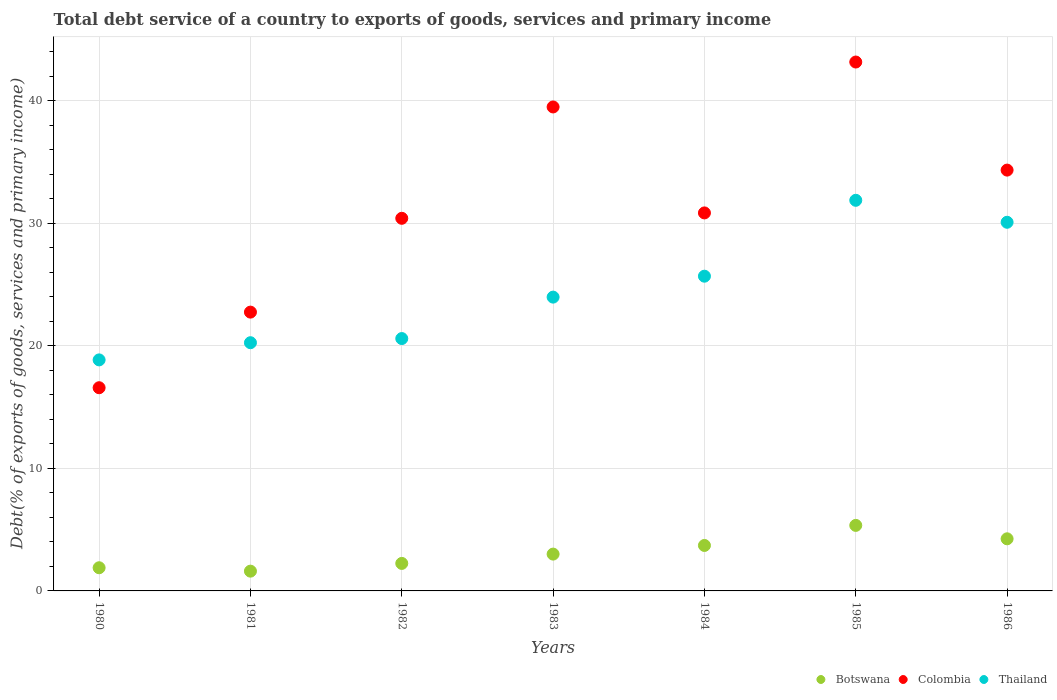How many different coloured dotlines are there?
Ensure brevity in your answer.  3. Is the number of dotlines equal to the number of legend labels?
Make the answer very short. Yes. What is the total debt service in Colombia in 1985?
Offer a very short reply. 43.18. Across all years, what is the maximum total debt service in Colombia?
Make the answer very short. 43.18. Across all years, what is the minimum total debt service in Colombia?
Give a very brief answer. 16.59. In which year was the total debt service in Colombia maximum?
Offer a very short reply. 1985. What is the total total debt service in Botswana in the graph?
Keep it short and to the point. 22.07. What is the difference between the total debt service in Colombia in 1981 and that in 1983?
Offer a very short reply. -16.75. What is the difference between the total debt service in Thailand in 1984 and the total debt service in Botswana in 1986?
Your response must be concise. 21.44. What is the average total debt service in Botswana per year?
Make the answer very short. 3.15. In the year 1985, what is the difference between the total debt service in Colombia and total debt service in Thailand?
Offer a very short reply. 11.29. In how many years, is the total debt service in Colombia greater than 8 %?
Provide a succinct answer. 7. What is the ratio of the total debt service in Botswana in 1983 to that in 1985?
Give a very brief answer. 0.56. Is the total debt service in Colombia in 1981 less than that in 1982?
Your response must be concise. Yes. Is the difference between the total debt service in Colombia in 1984 and 1986 greater than the difference between the total debt service in Thailand in 1984 and 1986?
Offer a very short reply. Yes. What is the difference between the highest and the second highest total debt service in Botswana?
Make the answer very short. 1.1. What is the difference between the highest and the lowest total debt service in Thailand?
Keep it short and to the point. 13.03. Is the sum of the total debt service in Botswana in 1981 and 1982 greater than the maximum total debt service in Colombia across all years?
Your answer should be compact. No. Is it the case that in every year, the sum of the total debt service in Colombia and total debt service in Botswana  is greater than the total debt service in Thailand?
Provide a succinct answer. No. Is the total debt service in Colombia strictly less than the total debt service in Botswana over the years?
Offer a terse response. No. How many years are there in the graph?
Keep it short and to the point. 7. Does the graph contain any zero values?
Your answer should be very brief. No. Does the graph contain grids?
Provide a short and direct response. Yes. How many legend labels are there?
Offer a very short reply. 3. How are the legend labels stacked?
Keep it short and to the point. Horizontal. What is the title of the graph?
Provide a short and direct response. Total debt service of a country to exports of goods, services and primary income. What is the label or title of the Y-axis?
Provide a short and direct response. Debt(% of exports of goods, services and primary income). What is the Debt(% of exports of goods, services and primary income) in Botswana in 1980?
Offer a very short reply. 1.89. What is the Debt(% of exports of goods, services and primary income) of Colombia in 1980?
Ensure brevity in your answer.  16.59. What is the Debt(% of exports of goods, services and primary income) of Thailand in 1980?
Your response must be concise. 18.86. What is the Debt(% of exports of goods, services and primary income) of Botswana in 1981?
Your answer should be very brief. 1.61. What is the Debt(% of exports of goods, services and primary income) of Colombia in 1981?
Keep it short and to the point. 22.76. What is the Debt(% of exports of goods, services and primary income) in Thailand in 1981?
Give a very brief answer. 20.26. What is the Debt(% of exports of goods, services and primary income) in Botswana in 1982?
Your response must be concise. 2.25. What is the Debt(% of exports of goods, services and primary income) of Colombia in 1982?
Offer a very short reply. 30.42. What is the Debt(% of exports of goods, services and primary income) in Thailand in 1982?
Give a very brief answer. 20.6. What is the Debt(% of exports of goods, services and primary income) of Botswana in 1983?
Your response must be concise. 3.01. What is the Debt(% of exports of goods, services and primary income) in Colombia in 1983?
Provide a short and direct response. 39.51. What is the Debt(% of exports of goods, services and primary income) of Thailand in 1983?
Your answer should be very brief. 23.99. What is the Debt(% of exports of goods, services and primary income) of Botswana in 1984?
Give a very brief answer. 3.71. What is the Debt(% of exports of goods, services and primary income) of Colombia in 1984?
Offer a very short reply. 30.86. What is the Debt(% of exports of goods, services and primary income) in Thailand in 1984?
Provide a short and direct response. 25.7. What is the Debt(% of exports of goods, services and primary income) in Botswana in 1985?
Give a very brief answer. 5.35. What is the Debt(% of exports of goods, services and primary income) in Colombia in 1985?
Make the answer very short. 43.18. What is the Debt(% of exports of goods, services and primary income) in Thailand in 1985?
Your answer should be compact. 31.89. What is the Debt(% of exports of goods, services and primary income) in Botswana in 1986?
Keep it short and to the point. 4.25. What is the Debt(% of exports of goods, services and primary income) in Colombia in 1986?
Your answer should be very brief. 34.36. What is the Debt(% of exports of goods, services and primary income) in Thailand in 1986?
Your answer should be compact. 30.1. Across all years, what is the maximum Debt(% of exports of goods, services and primary income) of Botswana?
Your answer should be very brief. 5.35. Across all years, what is the maximum Debt(% of exports of goods, services and primary income) of Colombia?
Give a very brief answer. 43.18. Across all years, what is the maximum Debt(% of exports of goods, services and primary income) in Thailand?
Provide a short and direct response. 31.89. Across all years, what is the minimum Debt(% of exports of goods, services and primary income) in Botswana?
Your response must be concise. 1.61. Across all years, what is the minimum Debt(% of exports of goods, services and primary income) in Colombia?
Offer a terse response. 16.59. Across all years, what is the minimum Debt(% of exports of goods, services and primary income) of Thailand?
Ensure brevity in your answer.  18.86. What is the total Debt(% of exports of goods, services and primary income) of Botswana in the graph?
Keep it short and to the point. 22.07. What is the total Debt(% of exports of goods, services and primary income) in Colombia in the graph?
Give a very brief answer. 217.69. What is the total Debt(% of exports of goods, services and primary income) of Thailand in the graph?
Your answer should be compact. 171.4. What is the difference between the Debt(% of exports of goods, services and primary income) of Botswana in 1980 and that in 1981?
Give a very brief answer. 0.28. What is the difference between the Debt(% of exports of goods, services and primary income) in Colombia in 1980 and that in 1981?
Your answer should be compact. -6.17. What is the difference between the Debt(% of exports of goods, services and primary income) of Thailand in 1980 and that in 1981?
Provide a succinct answer. -1.4. What is the difference between the Debt(% of exports of goods, services and primary income) of Botswana in 1980 and that in 1982?
Offer a very short reply. -0.35. What is the difference between the Debt(% of exports of goods, services and primary income) of Colombia in 1980 and that in 1982?
Your answer should be very brief. -13.83. What is the difference between the Debt(% of exports of goods, services and primary income) of Thailand in 1980 and that in 1982?
Offer a terse response. -1.74. What is the difference between the Debt(% of exports of goods, services and primary income) in Botswana in 1980 and that in 1983?
Offer a very short reply. -1.11. What is the difference between the Debt(% of exports of goods, services and primary income) of Colombia in 1980 and that in 1983?
Make the answer very short. -22.92. What is the difference between the Debt(% of exports of goods, services and primary income) in Thailand in 1980 and that in 1983?
Your answer should be very brief. -5.12. What is the difference between the Debt(% of exports of goods, services and primary income) in Botswana in 1980 and that in 1984?
Your answer should be compact. -1.82. What is the difference between the Debt(% of exports of goods, services and primary income) of Colombia in 1980 and that in 1984?
Keep it short and to the point. -14.27. What is the difference between the Debt(% of exports of goods, services and primary income) of Thailand in 1980 and that in 1984?
Offer a terse response. -6.83. What is the difference between the Debt(% of exports of goods, services and primary income) in Botswana in 1980 and that in 1985?
Offer a very short reply. -3.46. What is the difference between the Debt(% of exports of goods, services and primary income) of Colombia in 1980 and that in 1985?
Give a very brief answer. -26.59. What is the difference between the Debt(% of exports of goods, services and primary income) of Thailand in 1980 and that in 1985?
Make the answer very short. -13.03. What is the difference between the Debt(% of exports of goods, services and primary income) in Botswana in 1980 and that in 1986?
Ensure brevity in your answer.  -2.36. What is the difference between the Debt(% of exports of goods, services and primary income) of Colombia in 1980 and that in 1986?
Offer a very short reply. -17.77. What is the difference between the Debt(% of exports of goods, services and primary income) of Thailand in 1980 and that in 1986?
Your response must be concise. -11.24. What is the difference between the Debt(% of exports of goods, services and primary income) of Botswana in 1981 and that in 1982?
Make the answer very short. -0.63. What is the difference between the Debt(% of exports of goods, services and primary income) in Colombia in 1981 and that in 1982?
Your response must be concise. -7.66. What is the difference between the Debt(% of exports of goods, services and primary income) in Thailand in 1981 and that in 1982?
Keep it short and to the point. -0.34. What is the difference between the Debt(% of exports of goods, services and primary income) of Botswana in 1981 and that in 1983?
Provide a succinct answer. -1.39. What is the difference between the Debt(% of exports of goods, services and primary income) in Colombia in 1981 and that in 1983?
Keep it short and to the point. -16.75. What is the difference between the Debt(% of exports of goods, services and primary income) in Thailand in 1981 and that in 1983?
Offer a terse response. -3.72. What is the difference between the Debt(% of exports of goods, services and primary income) of Botswana in 1981 and that in 1984?
Keep it short and to the point. -2.1. What is the difference between the Debt(% of exports of goods, services and primary income) in Colombia in 1981 and that in 1984?
Offer a terse response. -8.1. What is the difference between the Debt(% of exports of goods, services and primary income) of Thailand in 1981 and that in 1984?
Make the answer very short. -5.43. What is the difference between the Debt(% of exports of goods, services and primary income) of Botswana in 1981 and that in 1985?
Give a very brief answer. -3.74. What is the difference between the Debt(% of exports of goods, services and primary income) of Colombia in 1981 and that in 1985?
Make the answer very short. -20.42. What is the difference between the Debt(% of exports of goods, services and primary income) in Thailand in 1981 and that in 1985?
Offer a very short reply. -11.63. What is the difference between the Debt(% of exports of goods, services and primary income) in Botswana in 1981 and that in 1986?
Your response must be concise. -2.64. What is the difference between the Debt(% of exports of goods, services and primary income) in Colombia in 1981 and that in 1986?
Give a very brief answer. -11.6. What is the difference between the Debt(% of exports of goods, services and primary income) of Thailand in 1981 and that in 1986?
Your answer should be very brief. -9.83. What is the difference between the Debt(% of exports of goods, services and primary income) of Botswana in 1982 and that in 1983?
Provide a short and direct response. -0.76. What is the difference between the Debt(% of exports of goods, services and primary income) of Colombia in 1982 and that in 1983?
Offer a very short reply. -9.09. What is the difference between the Debt(% of exports of goods, services and primary income) of Thailand in 1982 and that in 1983?
Keep it short and to the point. -3.38. What is the difference between the Debt(% of exports of goods, services and primary income) of Botswana in 1982 and that in 1984?
Offer a very short reply. -1.47. What is the difference between the Debt(% of exports of goods, services and primary income) in Colombia in 1982 and that in 1984?
Provide a succinct answer. -0.44. What is the difference between the Debt(% of exports of goods, services and primary income) in Thailand in 1982 and that in 1984?
Your response must be concise. -5.09. What is the difference between the Debt(% of exports of goods, services and primary income) of Botswana in 1982 and that in 1985?
Ensure brevity in your answer.  -3.1. What is the difference between the Debt(% of exports of goods, services and primary income) in Colombia in 1982 and that in 1985?
Give a very brief answer. -12.76. What is the difference between the Debt(% of exports of goods, services and primary income) of Thailand in 1982 and that in 1985?
Ensure brevity in your answer.  -11.29. What is the difference between the Debt(% of exports of goods, services and primary income) in Botswana in 1982 and that in 1986?
Make the answer very short. -2.01. What is the difference between the Debt(% of exports of goods, services and primary income) of Colombia in 1982 and that in 1986?
Provide a succinct answer. -3.94. What is the difference between the Debt(% of exports of goods, services and primary income) in Thailand in 1982 and that in 1986?
Your answer should be very brief. -9.49. What is the difference between the Debt(% of exports of goods, services and primary income) in Botswana in 1983 and that in 1984?
Ensure brevity in your answer.  -0.71. What is the difference between the Debt(% of exports of goods, services and primary income) of Colombia in 1983 and that in 1984?
Your answer should be compact. 8.65. What is the difference between the Debt(% of exports of goods, services and primary income) of Thailand in 1983 and that in 1984?
Your answer should be compact. -1.71. What is the difference between the Debt(% of exports of goods, services and primary income) of Botswana in 1983 and that in 1985?
Provide a succinct answer. -2.34. What is the difference between the Debt(% of exports of goods, services and primary income) of Colombia in 1983 and that in 1985?
Your response must be concise. -3.67. What is the difference between the Debt(% of exports of goods, services and primary income) in Thailand in 1983 and that in 1985?
Offer a very short reply. -7.9. What is the difference between the Debt(% of exports of goods, services and primary income) in Botswana in 1983 and that in 1986?
Your response must be concise. -1.25. What is the difference between the Debt(% of exports of goods, services and primary income) in Colombia in 1983 and that in 1986?
Give a very brief answer. 5.16. What is the difference between the Debt(% of exports of goods, services and primary income) of Thailand in 1983 and that in 1986?
Give a very brief answer. -6.11. What is the difference between the Debt(% of exports of goods, services and primary income) of Botswana in 1984 and that in 1985?
Offer a terse response. -1.64. What is the difference between the Debt(% of exports of goods, services and primary income) in Colombia in 1984 and that in 1985?
Your response must be concise. -12.32. What is the difference between the Debt(% of exports of goods, services and primary income) in Thailand in 1984 and that in 1985?
Make the answer very short. -6.2. What is the difference between the Debt(% of exports of goods, services and primary income) of Botswana in 1984 and that in 1986?
Give a very brief answer. -0.54. What is the difference between the Debt(% of exports of goods, services and primary income) in Colombia in 1984 and that in 1986?
Your response must be concise. -3.5. What is the difference between the Debt(% of exports of goods, services and primary income) in Thailand in 1984 and that in 1986?
Your response must be concise. -4.4. What is the difference between the Debt(% of exports of goods, services and primary income) in Botswana in 1985 and that in 1986?
Your answer should be compact. 1.1. What is the difference between the Debt(% of exports of goods, services and primary income) in Colombia in 1985 and that in 1986?
Your answer should be compact. 8.82. What is the difference between the Debt(% of exports of goods, services and primary income) in Thailand in 1985 and that in 1986?
Make the answer very short. 1.79. What is the difference between the Debt(% of exports of goods, services and primary income) of Botswana in 1980 and the Debt(% of exports of goods, services and primary income) of Colombia in 1981?
Your response must be concise. -20.87. What is the difference between the Debt(% of exports of goods, services and primary income) in Botswana in 1980 and the Debt(% of exports of goods, services and primary income) in Thailand in 1981?
Give a very brief answer. -18.37. What is the difference between the Debt(% of exports of goods, services and primary income) of Colombia in 1980 and the Debt(% of exports of goods, services and primary income) of Thailand in 1981?
Offer a very short reply. -3.68. What is the difference between the Debt(% of exports of goods, services and primary income) of Botswana in 1980 and the Debt(% of exports of goods, services and primary income) of Colombia in 1982?
Provide a short and direct response. -28.53. What is the difference between the Debt(% of exports of goods, services and primary income) of Botswana in 1980 and the Debt(% of exports of goods, services and primary income) of Thailand in 1982?
Keep it short and to the point. -18.71. What is the difference between the Debt(% of exports of goods, services and primary income) in Colombia in 1980 and the Debt(% of exports of goods, services and primary income) in Thailand in 1982?
Your answer should be very brief. -4.01. What is the difference between the Debt(% of exports of goods, services and primary income) of Botswana in 1980 and the Debt(% of exports of goods, services and primary income) of Colombia in 1983?
Give a very brief answer. -37.62. What is the difference between the Debt(% of exports of goods, services and primary income) in Botswana in 1980 and the Debt(% of exports of goods, services and primary income) in Thailand in 1983?
Keep it short and to the point. -22.1. What is the difference between the Debt(% of exports of goods, services and primary income) in Colombia in 1980 and the Debt(% of exports of goods, services and primary income) in Thailand in 1983?
Make the answer very short. -7.4. What is the difference between the Debt(% of exports of goods, services and primary income) of Botswana in 1980 and the Debt(% of exports of goods, services and primary income) of Colombia in 1984?
Ensure brevity in your answer.  -28.97. What is the difference between the Debt(% of exports of goods, services and primary income) of Botswana in 1980 and the Debt(% of exports of goods, services and primary income) of Thailand in 1984?
Give a very brief answer. -23.8. What is the difference between the Debt(% of exports of goods, services and primary income) in Colombia in 1980 and the Debt(% of exports of goods, services and primary income) in Thailand in 1984?
Your answer should be very brief. -9.11. What is the difference between the Debt(% of exports of goods, services and primary income) in Botswana in 1980 and the Debt(% of exports of goods, services and primary income) in Colombia in 1985?
Offer a terse response. -41.29. What is the difference between the Debt(% of exports of goods, services and primary income) in Botswana in 1980 and the Debt(% of exports of goods, services and primary income) in Thailand in 1985?
Your response must be concise. -30. What is the difference between the Debt(% of exports of goods, services and primary income) of Colombia in 1980 and the Debt(% of exports of goods, services and primary income) of Thailand in 1985?
Offer a very short reply. -15.3. What is the difference between the Debt(% of exports of goods, services and primary income) of Botswana in 1980 and the Debt(% of exports of goods, services and primary income) of Colombia in 1986?
Offer a very short reply. -32.47. What is the difference between the Debt(% of exports of goods, services and primary income) in Botswana in 1980 and the Debt(% of exports of goods, services and primary income) in Thailand in 1986?
Keep it short and to the point. -28.21. What is the difference between the Debt(% of exports of goods, services and primary income) of Colombia in 1980 and the Debt(% of exports of goods, services and primary income) of Thailand in 1986?
Provide a short and direct response. -13.51. What is the difference between the Debt(% of exports of goods, services and primary income) in Botswana in 1981 and the Debt(% of exports of goods, services and primary income) in Colombia in 1982?
Ensure brevity in your answer.  -28.81. What is the difference between the Debt(% of exports of goods, services and primary income) of Botswana in 1981 and the Debt(% of exports of goods, services and primary income) of Thailand in 1982?
Offer a very short reply. -18.99. What is the difference between the Debt(% of exports of goods, services and primary income) in Colombia in 1981 and the Debt(% of exports of goods, services and primary income) in Thailand in 1982?
Offer a very short reply. 2.16. What is the difference between the Debt(% of exports of goods, services and primary income) of Botswana in 1981 and the Debt(% of exports of goods, services and primary income) of Colombia in 1983?
Keep it short and to the point. -37.9. What is the difference between the Debt(% of exports of goods, services and primary income) in Botswana in 1981 and the Debt(% of exports of goods, services and primary income) in Thailand in 1983?
Make the answer very short. -22.37. What is the difference between the Debt(% of exports of goods, services and primary income) in Colombia in 1981 and the Debt(% of exports of goods, services and primary income) in Thailand in 1983?
Offer a terse response. -1.22. What is the difference between the Debt(% of exports of goods, services and primary income) in Botswana in 1981 and the Debt(% of exports of goods, services and primary income) in Colombia in 1984?
Give a very brief answer. -29.25. What is the difference between the Debt(% of exports of goods, services and primary income) in Botswana in 1981 and the Debt(% of exports of goods, services and primary income) in Thailand in 1984?
Offer a very short reply. -24.08. What is the difference between the Debt(% of exports of goods, services and primary income) of Colombia in 1981 and the Debt(% of exports of goods, services and primary income) of Thailand in 1984?
Your answer should be compact. -2.93. What is the difference between the Debt(% of exports of goods, services and primary income) in Botswana in 1981 and the Debt(% of exports of goods, services and primary income) in Colombia in 1985?
Make the answer very short. -41.57. What is the difference between the Debt(% of exports of goods, services and primary income) of Botswana in 1981 and the Debt(% of exports of goods, services and primary income) of Thailand in 1985?
Your response must be concise. -30.28. What is the difference between the Debt(% of exports of goods, services and primary income) in Colombia in 1981 and the Debt(% of exports of goods, services and primary income) in Thailand in 1985?
Ensure brevity in your answer.  -9.13. What is the difference between the Debt(% of exports of goods, services and primary income) of Botswana in 1981 and the Debt(% of exports of goods, services and primary income) of Colombia in 1986?
Offer a terse response. -32.74. What is the difference between the Debt(% of exports of goods, services and primary income) of Botswana in 1981 and the Debt(% of exports of goods, services and primary income) of Thailand in 1986?
Give a very brief answer. -28.48. What is the difference between the Debt(% of exports of goods, services and primary income) of Colombia in 1981 and the Debt(% of exports of goods, services and primary income) of Thailand in 1986?
Keep it short and to the point. -7.34. What is the difference between the Debt(% of exports of goods, services and primary income) of Botswana in 1982 and the Debt(% of exports of goods, services and primary income) of Colombia in 1983?
Provide a short and direct response. -37.27. What is the difference between the Debt(% of exports of goods, services and primary income) of Botswana in 1982 and the Debt(% of exports of goods, services and primary income) of Thailand in 1983?
Offer a terse response. -21.74. What is the difference between the Debt(% of exports of goods, services and primary income) of Colombia in 1982 and the Debt(% of exports of goods, services and primary income) of Thailand in 1983?
Your answer should be compact. 6.44. What is the difference between the Debt(% of exports of goods, services and primary income) of Botswana in 1982 and the Debt(% of exports of goods, services and primary income) of Colombia in 1984?
Keep it short and to the point. -28.62. What is the difference between the Debt(% of exports of goods, services and primary income) of Botswana in 1982 and the Debt(% of exports of goods, services and primary income) of Thailand in 1984?
Provide a succinct answer. -23.45. What is the difference between the Debt(% of exports of goods, services and primary income) in Colombia in 1982 and the Debt(% of exports of goods, services and primary income) in Thailand in 1984?
Give a very brief answer. 4.73. What is the difference between the Debt(% of exports of goods, services and primary income) of Botswana in 1982 and the Debt(% of exports of goods, services and primary income) of Colombia in 1985?
Offer a very short reply. -40.93. What is the difference between the Debt(% of exports of goods, services and primary income) of Botswana in 1982 and the Debt(% of exports of goods, services and primary income) of Thailand in 1985?
Keep it short and to the point. -29.65. What is the difference between the Debt(% of exports of goods, services and primary income) in Colombia in 1982 and the Debt(% of exports of goods, services and primary income) in Thailand in 1985?
Offer a terse response. -1.47. What is the difference between the Debt(% of exports of goods, services and primary income) in Botswana in 1982 and the Debt(% of exports of goods, services and primary income) in Colombia in 1986?
Your response must be concise. -32.11. What is the difference between the Debt(% of exports of goods, services and primary income) in Botswana in 1982 and the Debt(% of exports of goods, services and primary income) in Thailand in 1986?
Your response must be concise. -27.85. What is the difference between the Debt(% of exports of goods, services and primary income) of Colombia in 1982 and the Debt(% of exports of goods, services and primary income) of Thailand in 1986?
Make the answer very short. 0.32. What is the difference between the Debt(% of exports of goods, services and primary income) in Botswana in 1983 and the Debt(% of exports of goods, services and primary income) in Colombia in 1984?
Your answer should be very brief. -27.86. What is the difference between the Debt(% of exports of goods, services and primary income) in Botswana in 1983 and the Debt(% of exports of goods, services and primary income) in Thailand in 1984?
Provide a succinct answer. -22.69. What is the difference between the Debt(% of exports of goods, services and primary income) of Colombia in 1983 and the Debt(% of exports of goods, services and primary income) of Thailand in 1984?
Your answer should be very brief. 13.82. What is the difference between the Debt(% of exports of goods, services and primary income) in Botswana in 1983 and the Debt(% of exports of goods, services and primary income) in Colombia in 1985?
Ensure brevity in your answer.  -40.17. What is the difference between the Debt(% of exports of goods, services and primary income) of Botswana in 1983 and the Debt(% of exports of goods, services and primary income) of Thailand in 1985?
Provide a succinct answer. -28.89. What is the difference between the Debt(% of exports of goods, services and primary income) of Colombia in 1983 and the Debt(% of exports of goods, services and primary income) of Thailand in 1985?
Your answer should be very brief. 7.62. What is the difference between the Debt(% of exports of goods, services and primary income) in Botswana in 1983 and the Debt(% of exports of goods, services and primary income) in Colombia in 1986?
Provide a succinct answer. -31.35. What is the difference between the Debt(% of exports of goods, services and primary income) in Botswana in 1983 and the Debt(% of exports of goods, services and primary income) in Thailand in 1986?
Offer a very short reply. -27.09. What is the difference between the Debt(% of exports of goods, services and primary income) in Colombia in 1983 and the Debt(% of exports of goods, services and primary income) in Thailand in 1986?
Offer a very short reply. 9.42. What is the difference between the Debt(% of exports of goods, services and primary income) in Botswana in 1984 and the Debt(% of exports of goods, services and primary income) in Colombia in 1985?
Provide a succinct answer. -39.47. What is the difference between the Debt(% of exports of goods, services and primary income) in Botswana in 1984 and the Debt(% of exports of goods, services and primary income) in Thailand in 1985?
Offer a terse response. -28.18. What is the difference between the Debt(% of exports of goods, services and primary income) of Colombia in 1984 and the Debt(% of exports of goods, services and primary income) of Thailand in 1985?
Your answer should be compact. -1.03. What is the difference between the Debt(% of exports of goods, services and primary income) of Botswana in 1984 and the Debt(% of exports of goods, services and primary income) of Colombia in 1986?
Offer a terse response. -30.65. What is the difference between the Debt(% of exports of goods, services and primary income) of Botswana in 1984 and the Debt(% of exports of goods, services and primary income) of Thailand in 1986?
Make the answer very short. -26.39. What is the difference between the Debt(% of exports of goods, services and primary income) of Colombia in 1984 and the Debt(% of exports of goods, services and primary income) of Thailand in 1986?
Ensure brevity in your answer.  0.76. What is the difference between the Debt(% of exports of goods, services and primary income) in Botswana in 1985 and the Debt(% of exports of goods, services and primary income) in Colombia in 1986?
Offer a very short reply. -29.01. What is the difference between the Debt(% of exports of goods, services and primary income) in Botswana in 1985 and the Debt(% of exports of goods, services and primary income) in Thailand in 1986?
Ensure brevity in your answer.  -24.75. What is the difference between the Debt(% of exports of goods, services and primary income) of Colombia in 1985 and the Debt(% of exports of goods, services and primary income) of Thailand in 1986?
Offer a terse response. 13.08. What is the average Debt(% of exports of goods, services and primary income) of Botswana per year?
Your answer should be very brief. 3.15. What is the average Debt(% of exports of goods, services and primary income) in Colombia per year?
Give a very brief answer. 31.1. What is the average Debt(% of exports of goods, services and primary income) of Thailand per year?
Ensure brevity in your answer.  24.49. In the year 1980, what is the difference between the Debt(% of exports of goods, services and primary income) in Botswana and Debt(% of exports of goods, services and primary income) in Colombia?
Your answer should be compact. -14.7. In the year 1980, what is the difference between the Debt(% of exports of goods, services and primary income) in Botswana and Debt(% of exports of goods, services and primary income) in Thailand?
Keep it short and to the point. -16.97. In the year 1980, what is the difference between the Debt(% of exports of goods, services and primary income) of Colombia and Debt(% of exports of goods, services and primary income) of Thailand?
Provide a short and direct response. -2.27. In the year 1981, what is the difference between the Debt(% of exports of goods, services and primary income) in Botswana and Debt(% of exports of goods, services and primary income) in Colombia?
Offer a very short reply. -21.15. In the year 1981, what is the difference between the Debt(% of exports of goods, services and primary income) of Botswana and Debt(% of exports of goods, services and primary income) of Thailand?
Offer a very short reply. -18.65. In the year 1981, what is the difference between the Debt(% of exports of goods, services and primary income) in Colombia and Debt(% of exports of goods, services and primary income) in Thailand?
Provide a short and direct response. 2.5. In the year 1982, what is the difference between the Debt(% of exports of goods, services and primary income) of Botswana and Debt(% of exports of goods, services and primary income) of Colombia?
Offer a terse response. -28.18. In the year 1982, what is the difference between the Debt(% of exports of goods, services and primary income) of Botswana and Debt(% of exports of goods, services and primary income) of Thailand?
Your response must be concise. -18.36. In the year 1982, what is the difference between the Debt(% of exports of goods, services and primary income) in Colombia and Debt(% of exports of goods, services and primary income) in Thailand?
Your answer should be compact. 9.82. In the year 1983, what is the difference between the Debt(% of exports of goods, services and primary income) of Botswana and Debt(% of exports of goods, services and primary income) of Colombia?
Give a very brief answer. -36.51. In the year 1983, what is the difference between the Debt(% of exports of goods, services and primary income) of Botswana and Debt(% of exports of goods, services and primary income) of Thailand?
Your answer should be very brief. -20.98. In the year 1983, what is the difference between the Debt(% of exports of goods, services and primary income) of Colombia and Debt(% of exports of goods, services and primary income) of Thailand?
Offer a terse response. 15.53. In the year 1984, what is the difference between the Debt(% of exports of goods, services and primary income) in Botswana and Debt(% of exports of goods, services and primary income) in Colombia?
Keep it short and to the point. -27.15. In the year 1984, what is the difference between the Debt(% of exports of goods, services and primary income) in Botswana and Debt(% of exports of goods, services and primary income) in Thailand?
Offer a terse response. -21.98. In the year 1984, what is the difference between the Debt(% of exports of goods, services and primary income) of Colombia and Debt(% of exports of goods, services and primary income) of Thailand?
Ensure brevity in your answer.  5.17. In the year 1985, what is the difference between the Debt(% of exports of goods, services and primary income) of Botswana and Debt(% of exports of goods, services and primary income) of Colombia?
Ensure brevity in your answer.  -37.83. In the year 1985, what is the difference between the Debt(% of exports of goods, services and primary income) in Botswana and Debt(% of exports of goods, services and primary income) in Thailand?
Provide a succinct answer. -26.54. In the year 1985, what is the difference between the Debt(% of exports of goods, services and primary income) in Colombia and Debt(% of exports of goods, services and primary income) in Thailand?
Make the answer very short. 11.29. In the year 1986, what is the difference between the Debt(% of exports of goods, services and primary income) of Botswana and Debt(% of exports of goods, services and primary income) of Colombia?
Provide a short and direct response. -30.1. In the year 1986, what is the difference between the Debt(% of exports of goods, services and primary income) in Botswana and Debt(% of exports of goods, services and primary income) in Thailand?
Provide a short and direct response. -25.84. In the year 1986, what is the difference between the Debt(% of exports of goods, services and primary income) in Colombia and Debt(% of exports of goods, services and primary income) in Thailand?
Give a very brief answer. 4.26. What is the ratio of the Debt(% of exports of goods, services and primary income) of Botswana in 1980 to that in 1981?
Give a very brief answer. 1.17. What is the ratio of the Debt(% of exports of goods, services and primary income) of Colombia in 1980 to that in 1981?
Ensure brevity in your answer.  0.73. What is the ratio of the Debt(% of exports of goods, services and primary income) in Thailand in 1980 to that in 1981?
Your answer should be compact. 0.93. What is the ratio of the Debt(% of exports of goods, services and primary income) in Botswana in 1980 to that in 1982?
Keep it short and to the point. 0.84. What is the ratio of the Debt(% of exports of goods, services and primary income) in Colombia in 1980 to that in 1982?
Your response must be concise. 0.55. What is the ratio of the Debt(% of exports of goods, services and primary income) in Thailand in 1980 to that in 1982?
Ensure brevity in your answer.  0.92. What is the ratio of the Debt(% of exports of goods, services and primary income) in Botswana in 1980 to that in 1983?
Offer a terse response. 0.63. What is the ratio of the Debt(% of exports of goods, services and primary income) of Colombia in 1980 to that in 1983?
Keep it short and to the point. 0.42. What is the ratio of the Debt(% of exports of goods, services and primary income) in Thailand in 1980 to that in 1983?
Make the answer very short. 0.79. What is the ratio of the Debt(% of exports of goods, services and primary income) of Botswana in 1980 to that in 1984?
Keep it short and to the point. 0.51. What is the ratio of the Debt(% of exports of goods, services and primary income) of Colombia in 1980 to that in 1984?
Provide a succinct answer. 0.54. What is the ratio of the Debt(% of exports of goods, services and primary income) in Thailand in 1980 to that in 1984?
Give a very brief answer. 0.73. What is the ratio of the Debt(% of exports of goods, services and primary income) in Botswana in 1980 to that in 1985?
Offer a terse response. 0.35. What is the ratio of the Debt(% of exports of goods, services and primary income) in Colombia in 1980 to that in 1985?
Offer a terse response. 0.38. What is the ratio of the Debt(% of exports of goods, services and primary income) in Thailand in 1980 to that in 1985?
Ensure brevity in your answer.  0.59. What is the ratio of the Debt(% of exports of goods, services and primary income) in Botswana in 1980 to that in 1986?
Provide a short and direct response. 0.44. What is the ratio of the Debt(% of exports of goods, services and primary income) in Colombia in 1980 to that in 1986?
Offer a very short reply. 0.48. What is the ratio of the Debt(% of exports of goods, services and primary income) in Thailand in 1980 to that in 1986?
Your answer should be compact. 0.63. What is the ratio of the Debt(% of exports of goods, services and primary income) of Botswana in 1981 to that in 1982?
Provide a succinct answer. 0.72. What is the ratio of the Debt(% of exports of goods, services and primary income) in Colombia in 1981 to that in 1982?
Provide a succinct answer. 0.75. What is the ratio of the Debt(% of exports of goods, services and primary income) of Thailand in 1981 to that in 1982?
Ensure brevity in your answer.  0.98. What is the ratio of the Debt(% of exports of goods, services and primary income) of Botswana in 1981 to that in 1983?
Your answer should be compact. 0.54. What is the ratio of the Debt(% of exports of goods, services and primary income) in Colombia in 1981 to that in 1983?
Your answer should be very brief. 0.58. What is the ratio of the Debt(% of exports of goods, services and primary income) in Thailand in 1981 to that in 1983?
Your answer should be very brief. 0.84. What is the ratio of the Debt(% of exports of goods, services and primary income) of Botswana in 1981 to that in 1984?
Provide a succinct answer. 0.43. What is the ratio of the Debt(% of exports of goods, services and primary income) in Colombia in 1981 to that in 1984?
Make the answer very short. 0.74. What is the ratio of the Debt(% of exports of goods, services and primary income) of Thailand in 1981 to that in 1984?
Give a very brief answer. 0.79. What is the ratio of the Debt(% of exports of goods, services and primary income) in Botswana in 1981 to that in 1985?
Keep it short and to the point. 0.3. What is the ratio of the Debt(% of exports of goods, services and primary income) of Colombia in 1981 to that in 1985?
Offer a terse response. 0.53. What is the ratio of the Debt(% of exports of goods, services and primary income) in Thailand in 1981 to that in 1985?
Offer a terse response. 0.64. What is the ratio of the Debt(% of exports of goods, services and primary income) of Botswana in 1981 to that in 1986?
Make the answer very short. 0.38. What is the ratio of the Debt(% of exports of goods, services and primary income) in Colombia in 1981 to that in 1986?
Your response must be concise. 0.66. What is the ratio of the Debt(% of exports of goods, services and primary income) of Thailand in 1981 to that in 1986?
Your response must be concise. 0.67. What is the ratio of the Debt(% of exports of goods, services and primary income) in Botswana in 1982 to that in 1983?
Your answer should be compact. 0.75. What is the ratio of the Debt(% of exports of goods, services and primary income) of Colombia in 1982 to that in 1983?
Your answer should be very brief. 0.77. What is the ratio of the Debt(% of exports of goods, services and primary income) of Thailand in 1982 to that in 1983?
Provide a short and direct response. 0.86. What is the ratio of the Debt(% of exports of goods, services and primary income) in Botswana in 1982 to that in 1984?
Ensure brevity in your answer.  0.61. What is the ratio of the Debt(% of exports of goods, services and primary income) in Colombia in 1982 to that in 1984?
Your answer should be compact. 0.99. What is the ratio of the Debt(% of exports of goods, services and primary income) of Thailand in 1982 to that in 1984?
Ensure brevity in your answer.  0.8. What is the ratio of the Debt(% of exports of goods, services and primary income) in Botswana in 1982 to that in 1985?
Offer a terse response. 0.42. What is the ratio of the Debt(% of exports of goods, services and primary income) of Colombia in 1982 to that in 1985?
Make the answer very short. 0.7. What is the ratio of the Debt(% of exports of goods, services and primary income) of Thailand in 1982 to that in 1985?
Ensure brevity in your answer.  0.65. What is the ratio of the Debt(% of exports of goods, services and primary income) in Botswana in 1982 to that in 1986?
Your answer should be very brief. 0.53. What is the ratio of the Debt(% of exports of goods, services and primary income) in Colombia in 1982 to that in 1986?
Your answer should be very brief. 0.89. What is the ratio of the Debt(% of exports of goods, services and primary income) of Thailand in 1982 to that in 1986?
Keep it short and to the point. 0.68. What is the ratio of the Debt(% of exports of goods, services and primary income) in Botswana in 1983 to that in 1984?
Offer a very short reply. 0.81. What is the ratio of the Debt(% of exports of goods, services and primary income) of Colombia in 1983 to that in 1984?
Ensure brevity in your answer.  1.28. What is the ratio of the Debt(% of exports of goods, services and primary income) of Thailand in 1983 to that in 1984?
Your answer should be very brief. 0.93. What is the ratio of the Debt(% of exports of goods, services and primary income) of Botswana in 1983 to that in 1985?
Offer a terse response. 0.56. What is the ratio of the Debt(% of exports of goods, services and primary income) in Colombia in 1983 to that in 1985?
Provide a succinct answer. 0.92. What is the ratio of the Debt(% of exports of goods, services and primary income) in Thailand in 1983 to that in 1985?
Your answer should be compact. 0.75. What is the ratio of the Debt(% of exports of goods, services and primary income) in Botswana in 1983 to that in 1986?
Offer a terse response. 0.71. What is the ratio of the Debt(% of exports of goods, services and primary income) of Colombia in 1983 to that in 1986?
Provide a short and direct response. 1.15. What is the ratio of the Debt(% of exports of goods, services and primary income) in Thailand in 1983 to that in 1986?
Provide a short and direct response. 0.8. What is the ratio of the Debt(% of exports of goods, services and primary income) of Botswana in 1984 to that in 1985?
Offer a very short reply. 0.69. What is the ratio of the Debt(% of exports of goods, services and primary income) in Colombia in 1984 to that in 1985?
Provide a short and direct response. 0.71. What is the ratio of the Debt(% of exports of goods, services and primary income) in Thailand in 1984 to that in 1985?
Offer a terse response. 0.81. What is the ratio of the Debt(% of exports of goods, services and primary income) of Botswana in 1984 to that in 1986?
Provide a succinct answer. 0.87. What is the ratio of the Debt(% of exports of goods, services and primary income) in Colombia in 1984 to that in 1986?
Ensure brevity in your answer.  0.9. What is the ratio of the Debt(% of exports of goods, services and primary income) in Thailand in 1984 to that in 1986?
Provide a short and direct response. 0.85. What is the ratio of the Debt(% of exports of goods, services and primary income) of Botswana in 1985 to that in 1986?
Provide a succinct answer. 1.26. What is the ratio of the Debt(% of exports of goods, services and primary income) of Colombia in 1985 to that in 1986?
Keep it short and to the point. 1.26. What is the ratio of the Debt(% of exports of goods, services and primary income) in Thailand in 1985 to that in 1986?
Give a very brief answer. 1.06. What is the difference between the highest and the second highest Debt(% of exports of goods, services and primary income) in Botswana?
Ensure brevity in your answer.  1.1. What is the difference between the highest and the second highest Debt(% of exports of goods, services and primary income) of Colombia?
Offer a terse response. 3.67. What is the difference between the highest and the second highest Debt(% of exports of goods, services and primary income) of Thailand?
Your response must be concise. 1.79. What is the difference between the highest and the lowest Debt(% of exports of goods, services and primary income) in Botswana?
Make the answer very short. 3.74. What is the difference between the highest and the lowest Debt(% of exports of goods, services and primary income) in Colombia?
Offer a very short reply. 26.59. What is the difference between the highest and the lowest Debt(% of exports of goods, services and primary income) of Thailand?
Your answer should be compact. 13.03. 